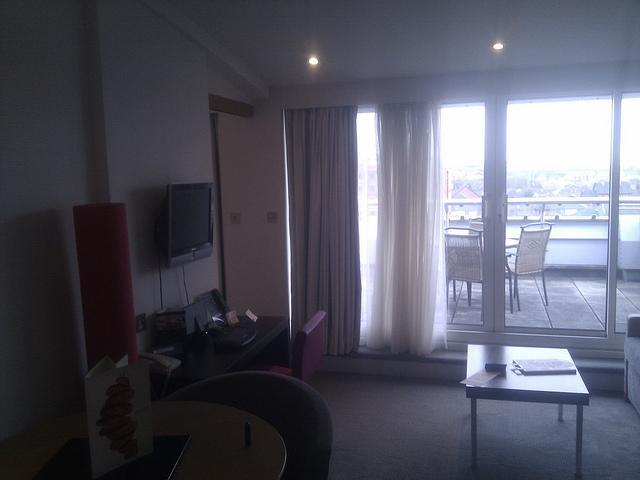How many lights are on in the room?
Give a very brief answer. 2. How many dining tables can be seen?
Give a very brief answer. 2. How many chairs can you see?
Give a very brief answer. 3. 